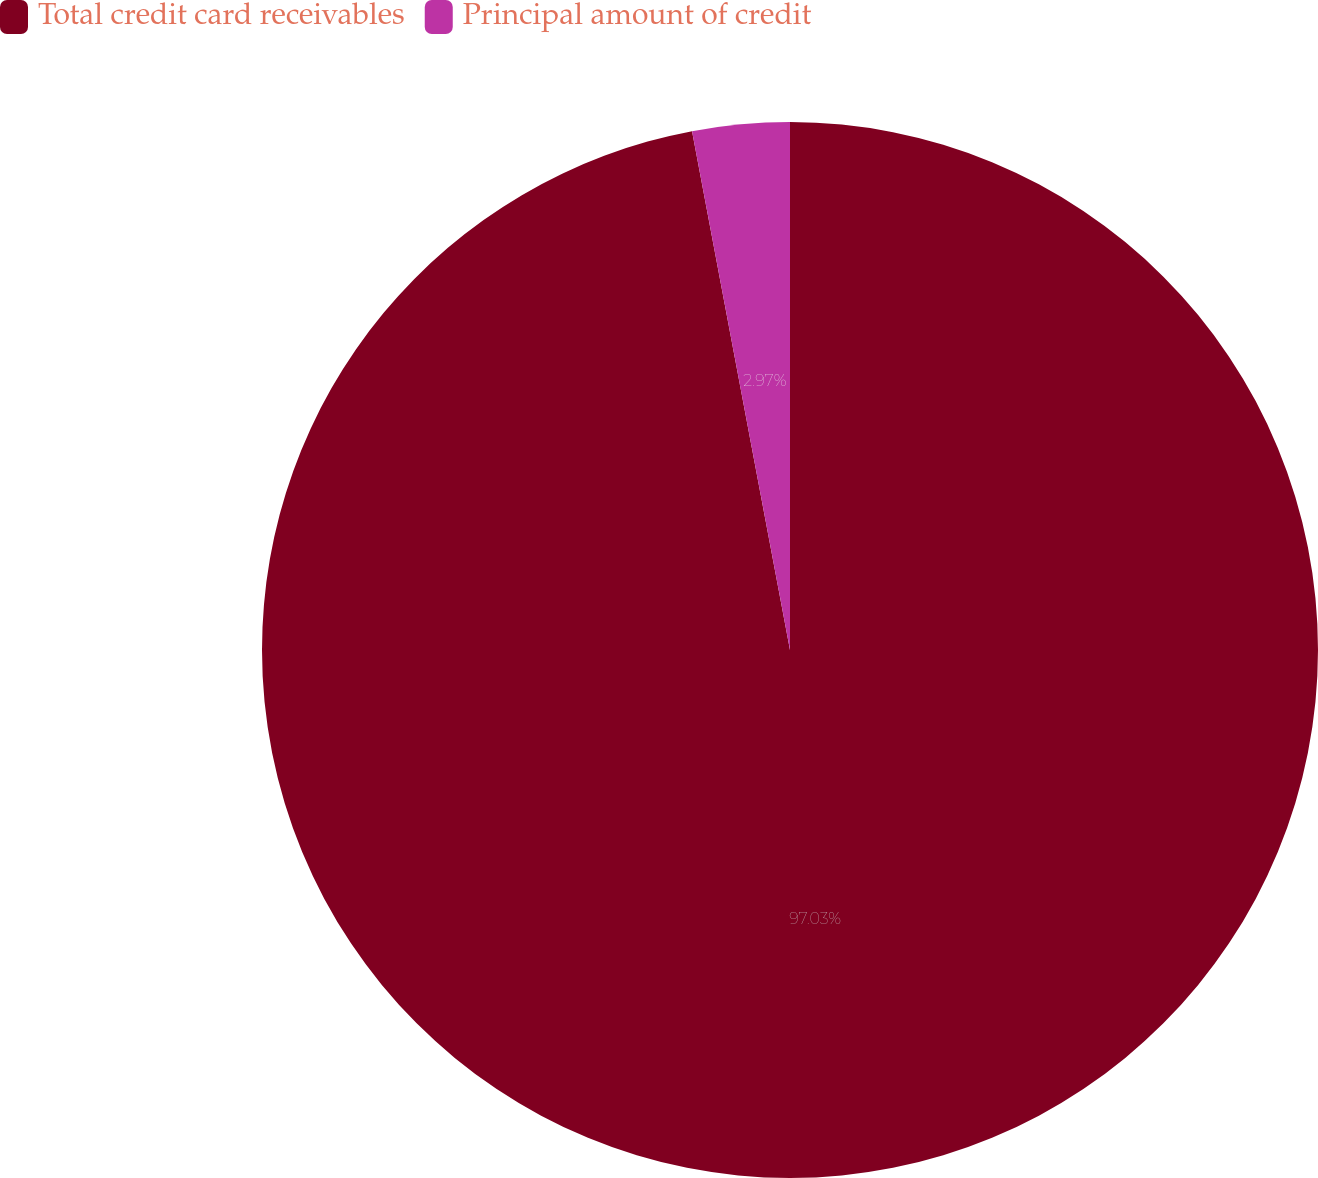Convert chart to OTSL. <chart><loc_0><loc_0><loc_500><loc_500><pie_chart><fcel>Total credit card receivables<fcel>Principal amount of credit<nl><fcel>97.03%<fcel>2.97%<nl></chart> 